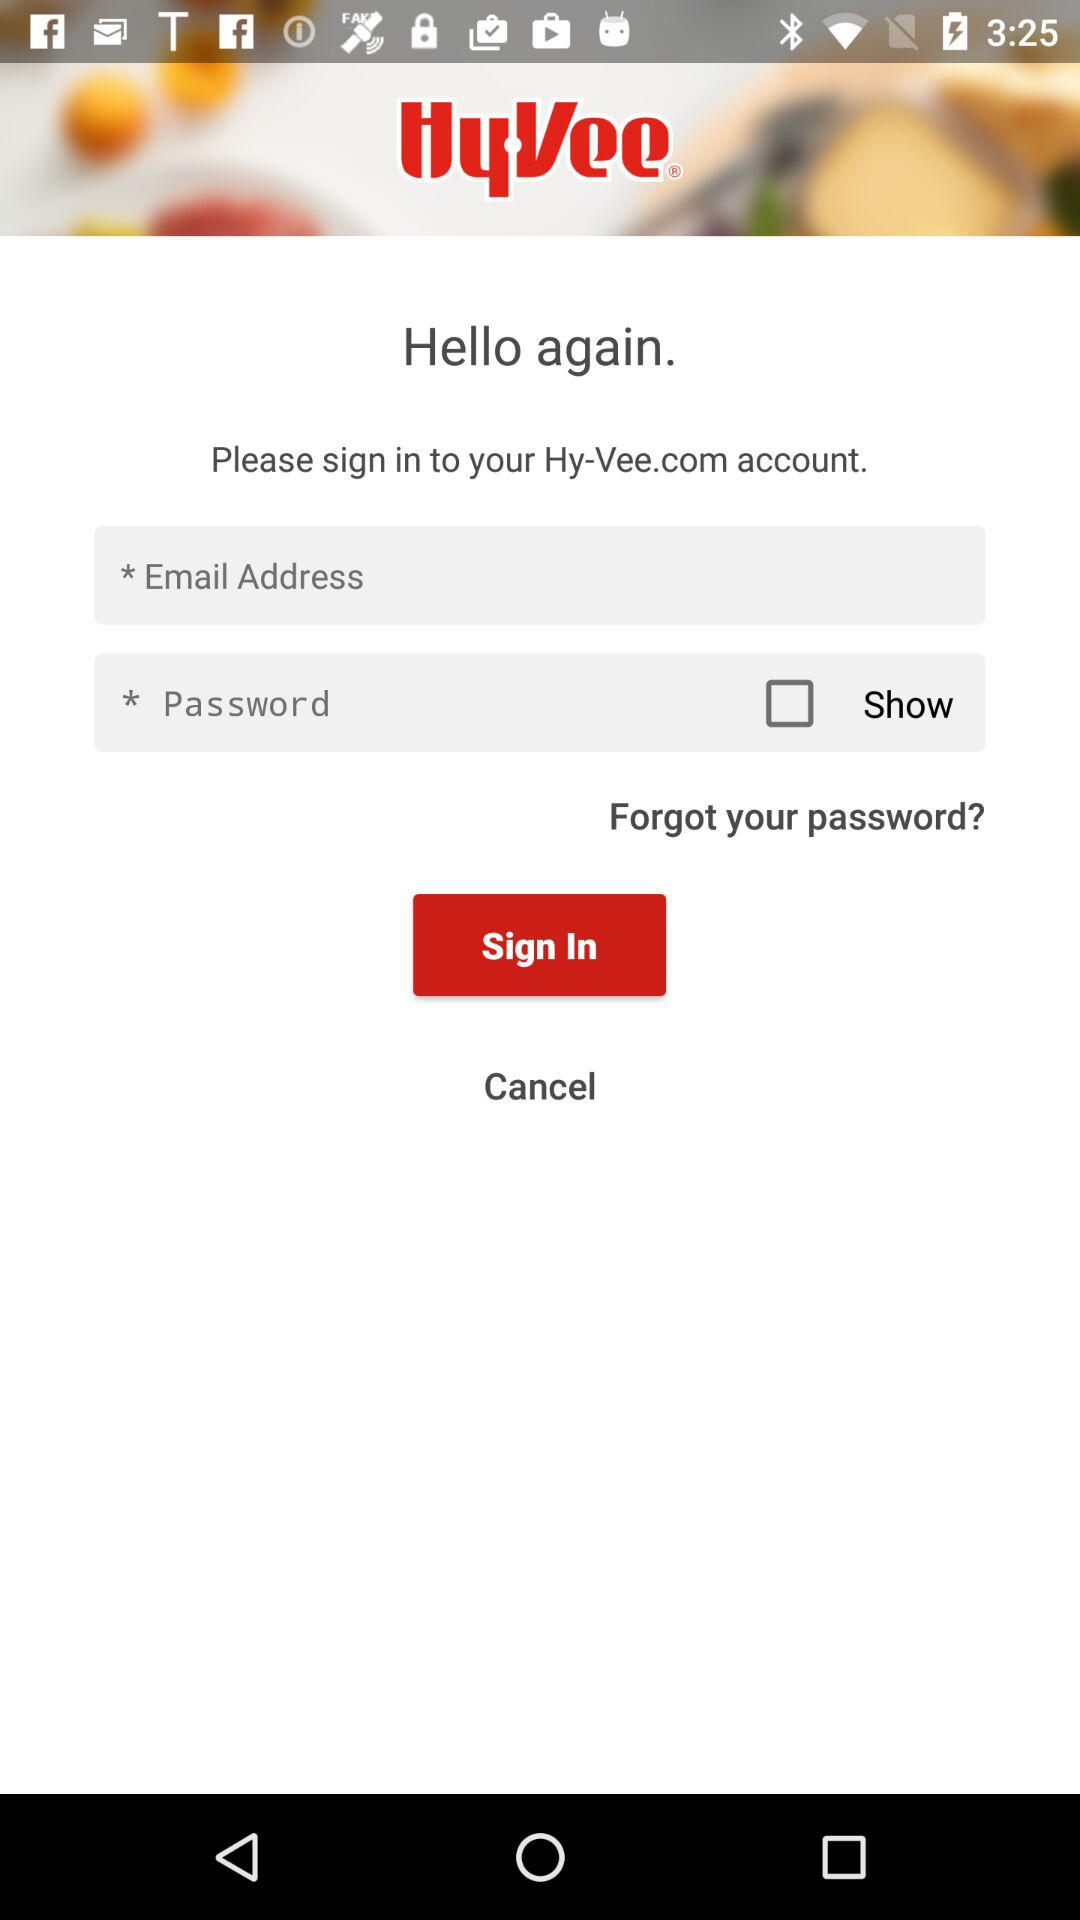What account do I need to sign in with? You need to sign in with your "Email" account. 